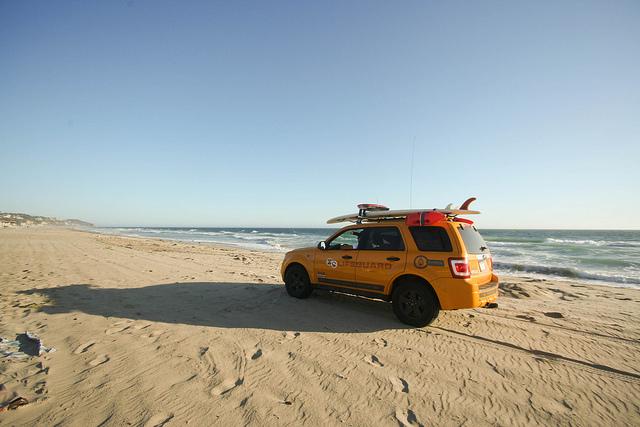Is the van going to go surfing?
Be succinct. No. What is the person's job inside the car?
Answer briefly. Lifeguard. Is it sunny?
Give a very brief answer. Yes. 